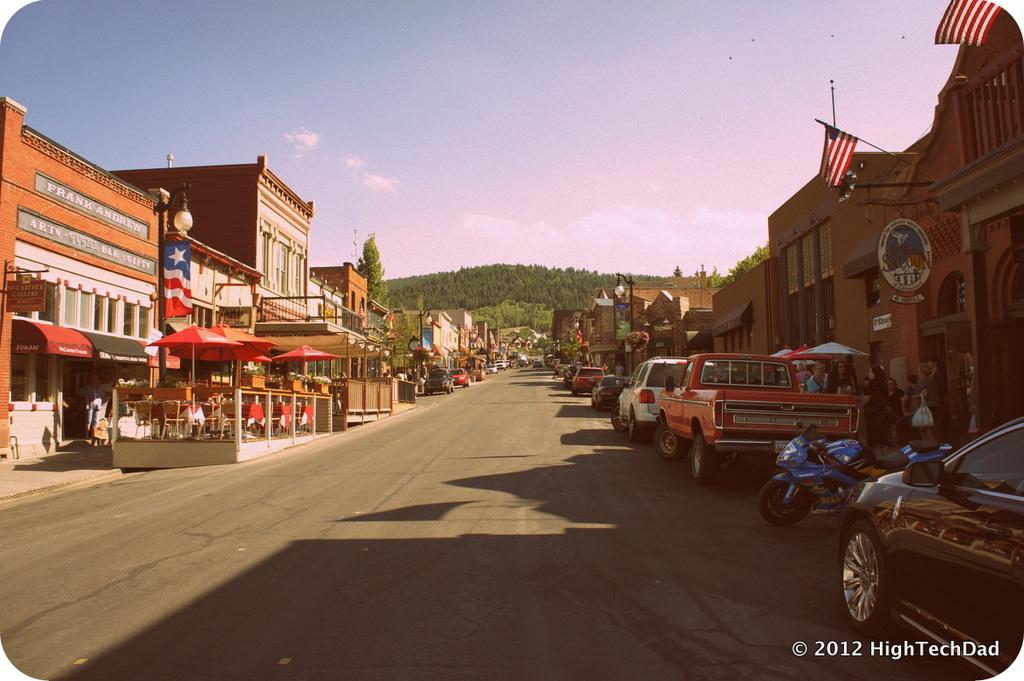What type of structures can be seen in the image? There are buildings in the image. What are the vertical structures on the sides of the road? Street poles are present in the image. What are the illuminated structures on the street poles? Street lights are visible in the image. What type of shade structures can be seen in the image? Parasols are in the image. What type of furniture is present in the image? Chairs and tables are visible in the image. What type of transportation is on the road in the image? Motor vehicles are on the road in the image. What are the people doing in the image? There are persons standing on the floor in the image. What type of vegetation is present in the image? Trees are present in the image. What is visible in the sky in the image? The sky is visible in the image, and clouds are present in the sky. Where is the mailbox located in the image? There is no mailbox present in the image. What type of furniture is inside the drawer in the image? There is no drawer present in the image. 